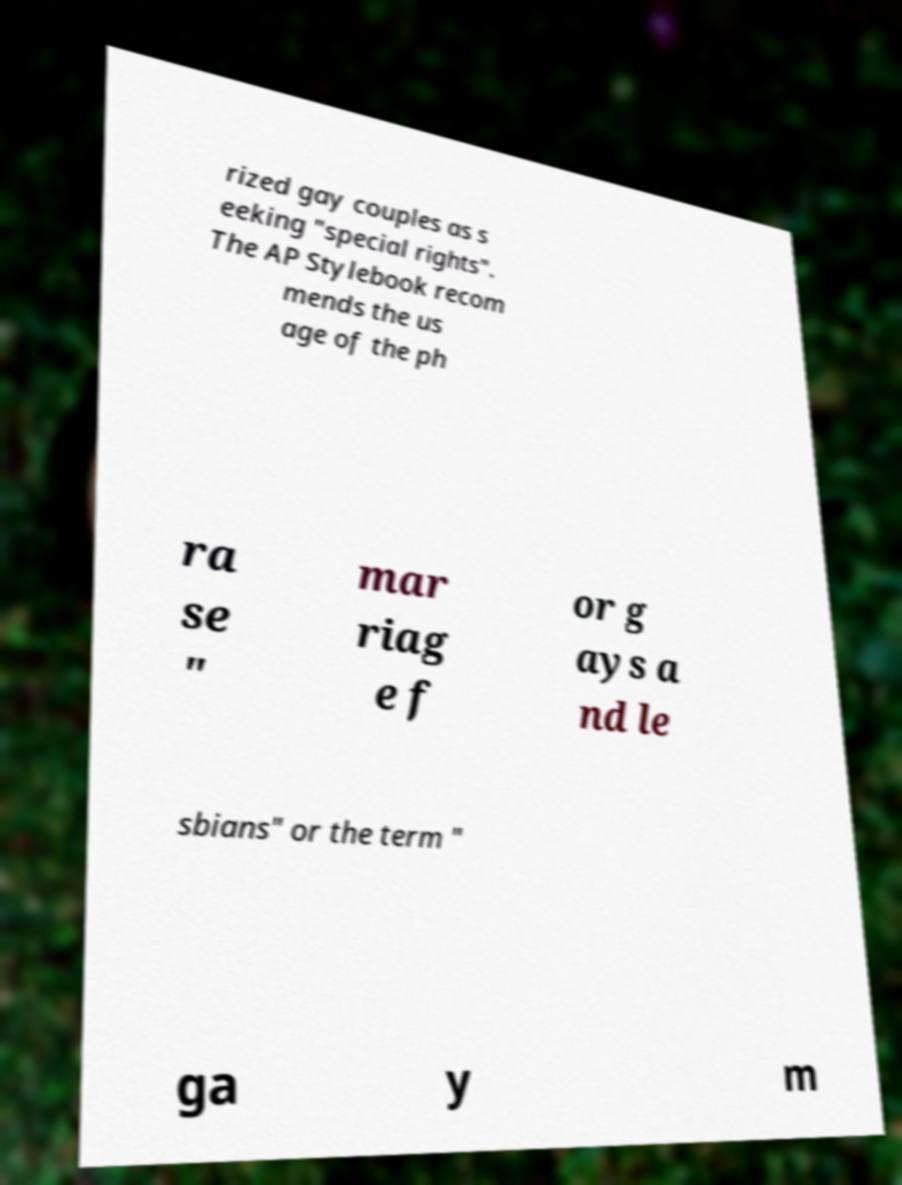Could you extract and type out the text from this image? rized gay couples as s eeking "special rights". The AP Stylebook recom mends the us age of the ph ra se " mar riag e f or g ays a nd le sbians" or the term " ga y m 